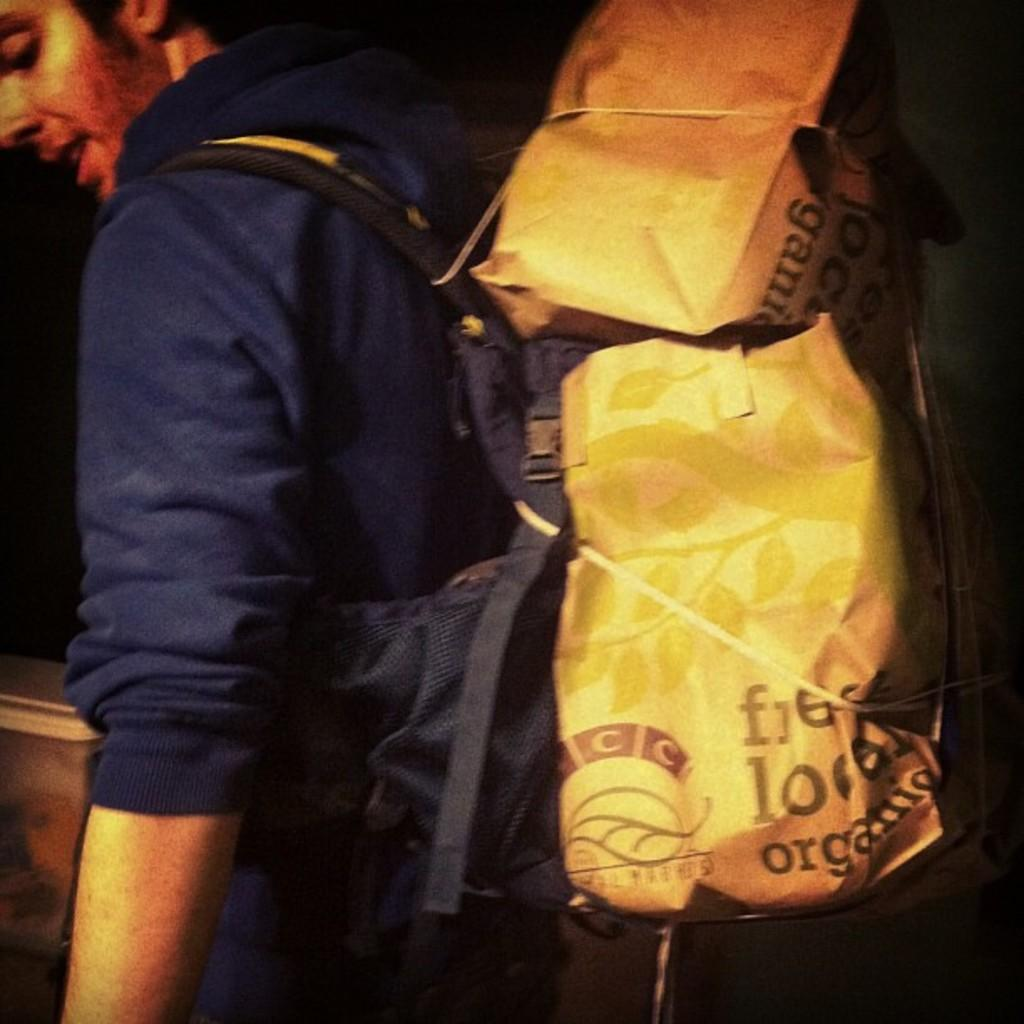Who or what is present in the image? There is a person in the image. What is the person wearing in the image? The person is wearing a bag. What type of thrill can be experienced by the person in the image? There is no indication of any thrill-related activity in the image, as it only shows a person wearing a bag. 